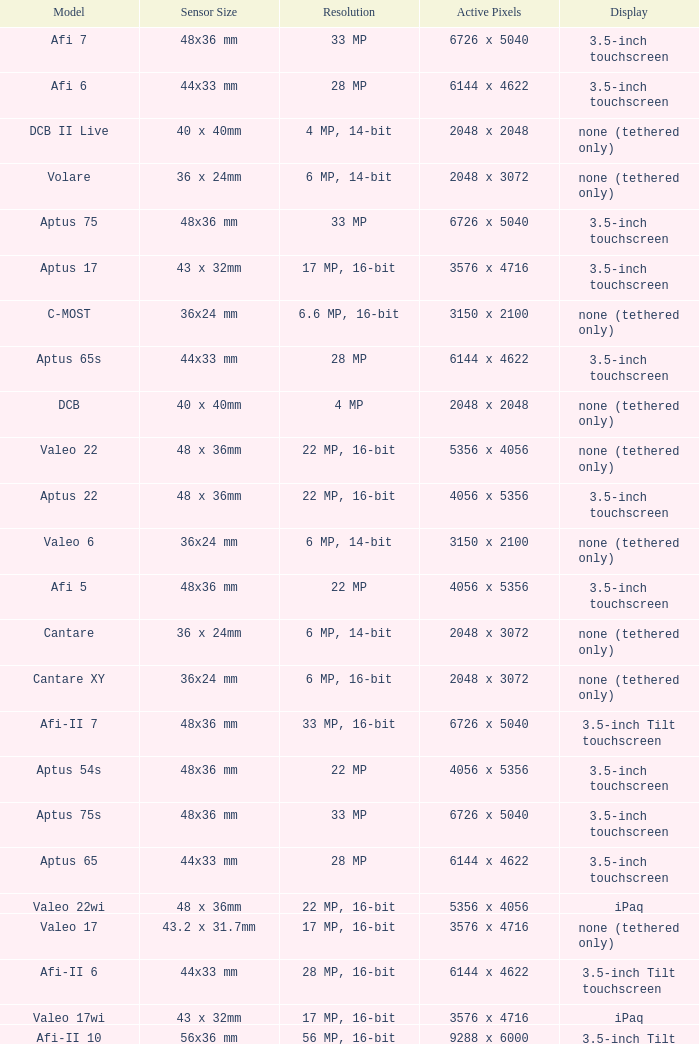Parse the table in full. {'header': ['Model', 'Sensor Size', 'Resolution', 'Active Pixels', 'Display'], 'rows': [['Afi 7', '48x36 mm', '33 MP', '6726 x 5040', '3.5-inch touchscreen'], ['Afi 6', '44x33 mm', '28 MP', '6144 x 4622', '3.5-inch touchscreen'], ['DCB II Live', '40 x 40mm', '4 MP, 14-bit', '2048 x 2048', 'none (tethered only)'], ['Volare', '36 x 24mm', '6 MP, 14-bit', '2048 x 3072', 'none (tethered only)'], ['Aptus 75', '48x36 mm', '33 MP', '6726 x 5040', '3.5-inch touchscreen'], ['Aptus 17', '43 x 32mm', '17 MP, 16-bit', '3576 x 4716', '3.5-inch touchscreen'], ['C-MOST', '36x24 mm', '6.6 MP, 16-bit', '3150 x 2100', 'none (tethered only)'], ['Aptus 65s', '44x33 mm', '28 MP', '6144 x 4622', '3.5-inch touchscreen'], ['DCB', '40 x 40mm', '4 MP', '2048 x 2048', 'none (tethered only)'], ['Valeo 22', '48 x 36mm', '22 MP, 16-bit', '5356 x 4056', 'none (tethered only)'], ['Aptus 22', '48 x 36mm', '22 MP, 16-bit', '4056 x 5356', '3.5-inch touchscreen'], ['Valeo 6', '36x24 mm', '6 MP, 14-bit', '3150 x 2100', 'none (tethered only)'], ['Afi 5', '48x36 mm', '22 MP', '4056 x 5356', '3.5-inch touchscreen'], ['Cantare', '36 x 24mm', '6 MP, 14-bit', '2048 x 3072', 'none (tethered only)'], ['Cantare XY', '36x24 mm', '6 MP, 16-bit', '2048 x 3072', 'none (tethered only)'], ['Afi-II 7', '48x36 mm', '33 MP, 16-bit', '6726 x 5040', '3.5-inch Tilt touchscreen'], ['Aptus 54s', '48x36 mm', '22 MP', '4056 x 5356', '3.5-inch touchscreen'], ['Aptus 75s', '48x36 mm', '33 MP', '6726 x 5040', '3.5-inch touchscreen'], ['Aptus 65', '44x33 mm', '28 MP', '6144 x 4622', '3.5-inch touchscreen'], ['Valeo 22wi', '48 x 36mm', '22 MP, 16-bit', '5356 x 4056', 'iPaq'], ['Valeo 17', '43.2 x 31.7mm', '17 MP, 16-bit', '3576 x 4716', 'none (tethered only)'], ['Afi-II 6', '44x33 mm', '28 MP, 16-bit', '6144 x 4622', '3.5-inch Tilt touchscreen'], ['Valeo 17wi', '43 x 32mm', '17 MP, 16-bit', '3576 x 4716', 'iPaq'], ['Afi-II 10', '56x36 mm', '56 MP, 16-bit', '9288 x 6000', '3.5-inch Tilt touchscreen'], ['Valeo 11', '36x24mm', '11 MP, 16-bit', '4056x2684', 'none (tethered only)']]} Which model has a sensor sized 48x36 mm, pixels of 6726 x 5040, and a 33 mp resolution? Afi 7, Aptus 75s, Aptus 75. 